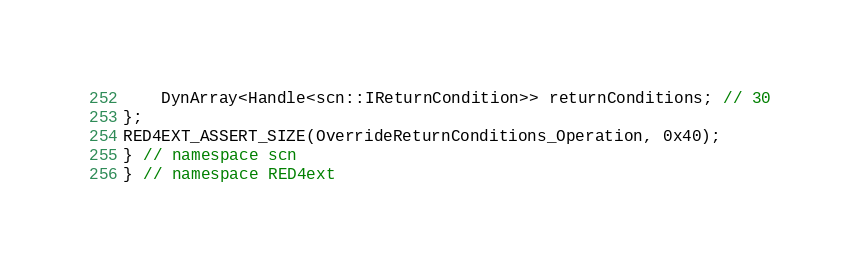Convert code to text. <code><loc_0><loc_0><loc_500><loc_500><_C++_>    DynArray<Handle<scn::IReturnCondition>> returnConditions; // 30
};
RED4EXT_ASSERT_SIZE(OverrideReturnConditions_Operation, 0x40);
} // namespace scn
} // namespace RED4ext
</code> 